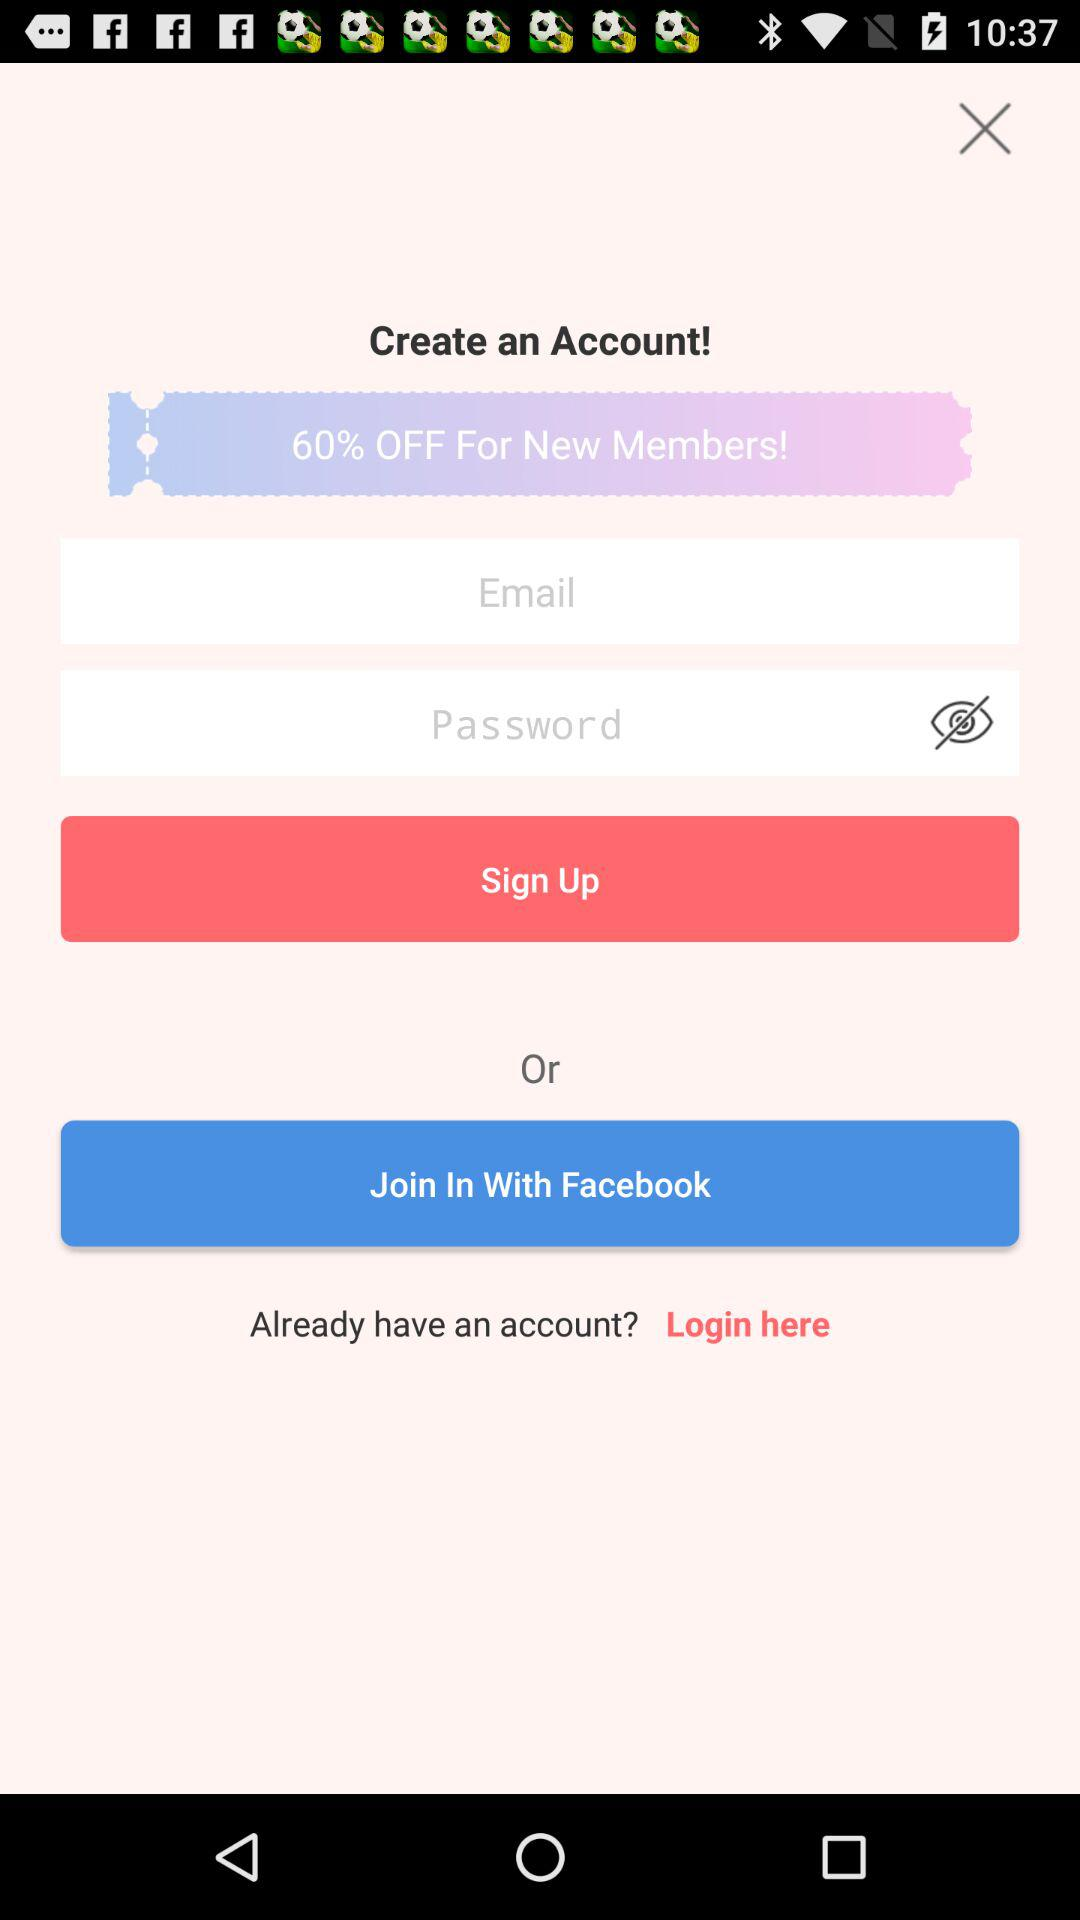How much of a percentage is off for new members? The percentage is 60. 